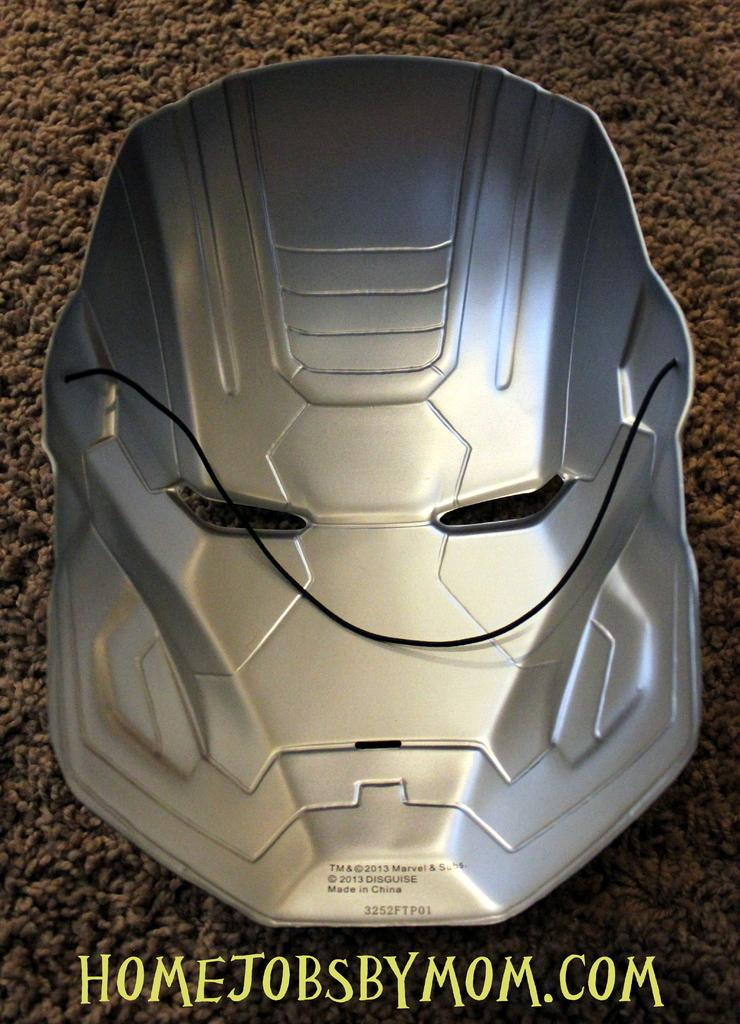What object is on the floor in the image? There is a mask present in the image. Can you describe the position of the mask in the image? The mask is on the floor. What type of sticks is the governor using to interact with the monkey in the image? There is no governor, sticks, or monkey present in the image; it only features a mask on the floor. 